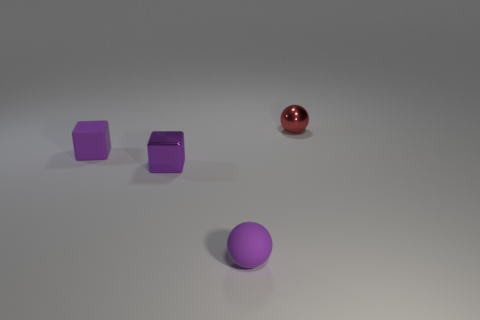Are the red object and the purple sphere made of the same material?
Give a very brief answer. No. Do the tiny metallic object to the left of the tiny red metallic sphere and the small purple rubber object that is behind the small purple metallic block have the same shape?
Keep it short and to the point. Yes. Do the red ball and the sphere that is left of the tiny shiny ball have the same size?
Your answer should be compact. Yes. What number of other things are the same material as the purple sphere?
Your response must be concise. 1. What color is the small rubber thing that is in front of the small purple matte object behind the rubber object on the right side of the purple metallic block?
Make the answer very short. Purple. What shape is the tiny thing that is to the left of the small purple matte ball and behind the small metallic block?
Keep it short and to the point. Cube. What color is the tiny shiny object in front of the sphere behind the small matte sphere?
Offer a very short reply. Purple. There is a purple rubber object that is behind the rubber object that is to the right of the matte thing that is behind the tiny metal block; what is its shape?
Offer a terse response. Cube. There is a thing that is left of the small red thing and right of the purple metal cube; what size is it?
Keep it short and to the point. Small. What number of tiny rubber balls have the same color as the rubber block?
Give a very brief answer. 1. 